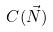<formula> <loc_0><loc_0><loc_500><loc_500>C ( \vec { N } )</formula> 